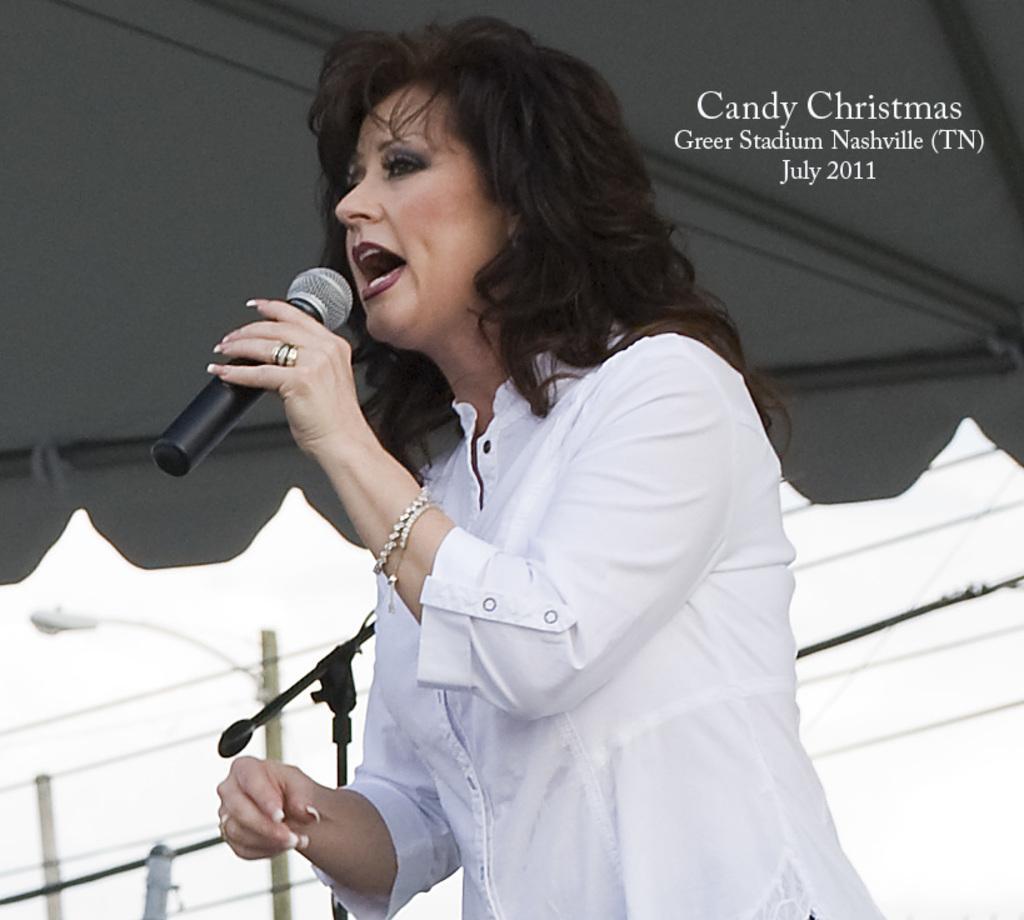Please provide a concise description of this image. The image is taken outside. There is a woman in the image. She is wearing a white dress and holding a mic in her hand. At the top, there is a tent. Behind her there is a mic stand. And building in the background. 